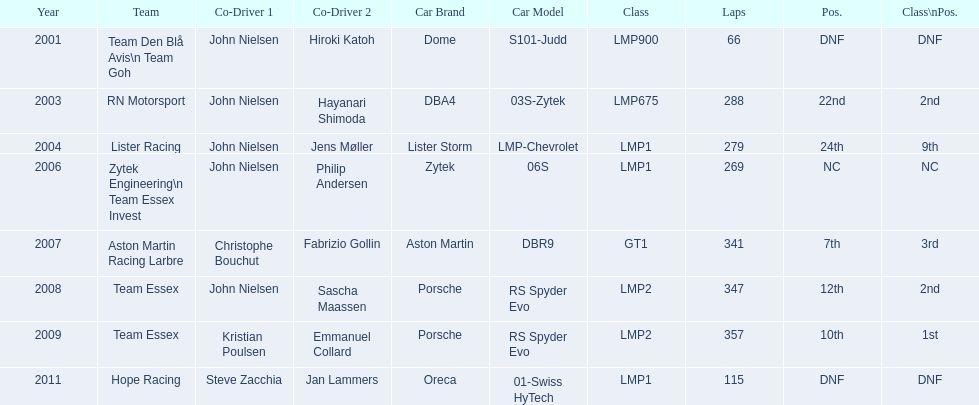Who were the co-drivers for the aston martin dbr9 in 2007? Christophe Bouchut, Fabrizio Gollin. 